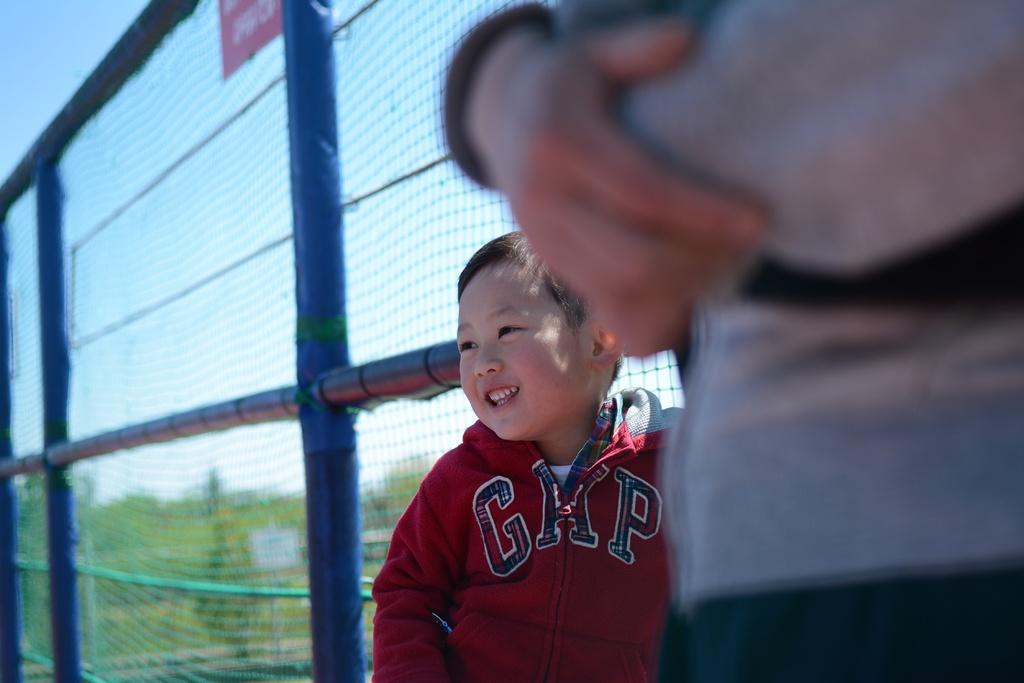<image>
Describe the image concisely. A child wearing a red GAP hoodie stands next to a fence. 